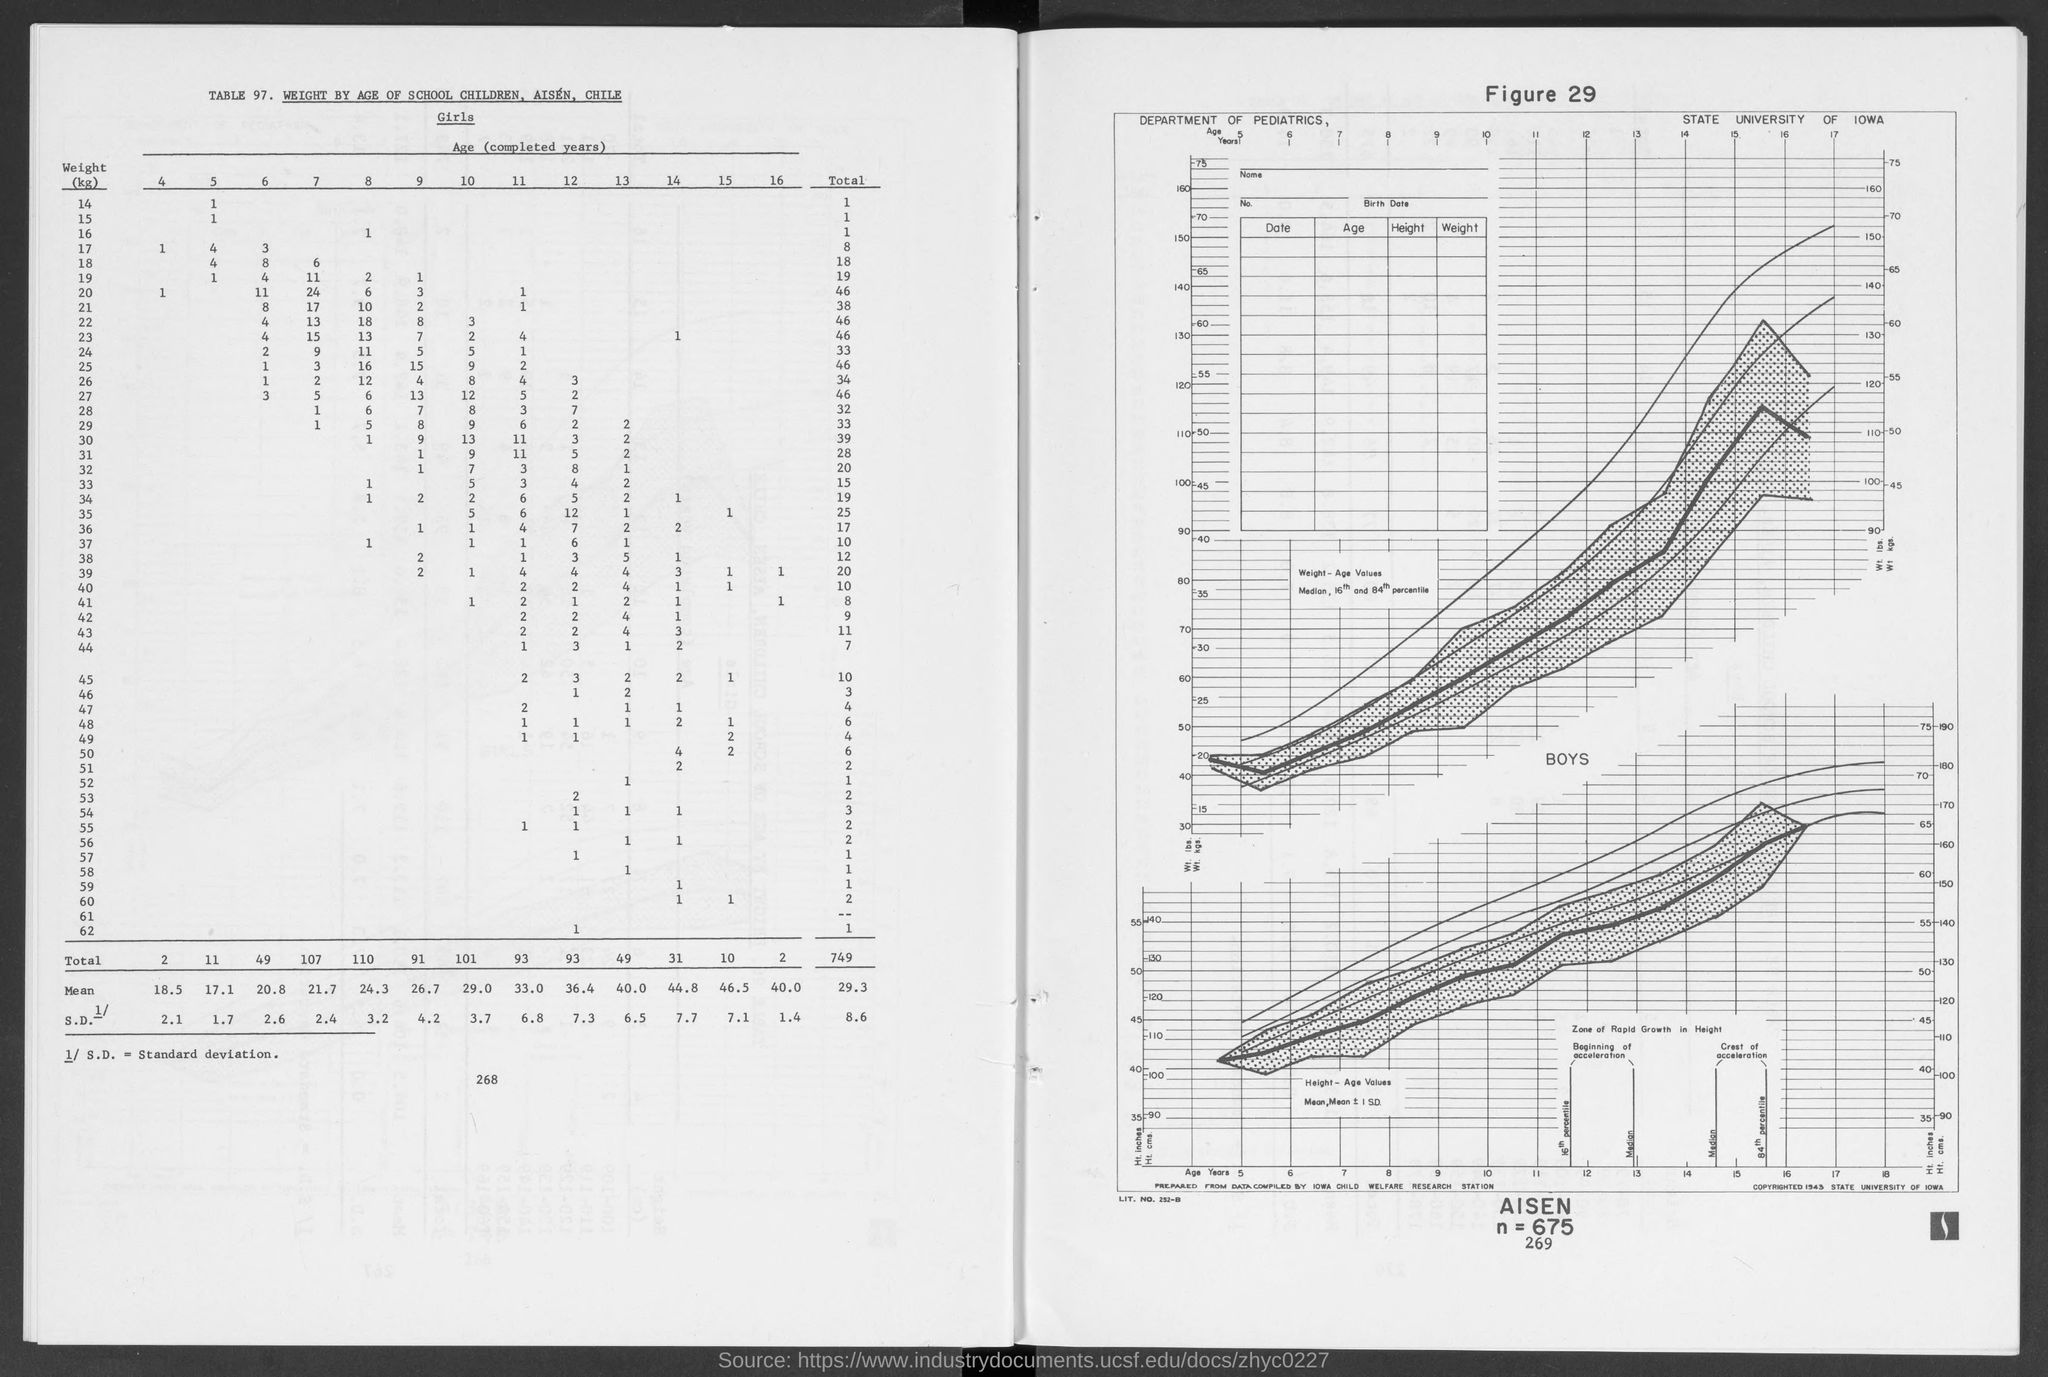What is the number of children having weight 14 of age 5?
Your answer should be compact. 1. What is the number of children having weight 17 of age 6?
Provide a short and direct response. 3. What is the total number of children having weight 45?
Your answer should be very brief. 10. 